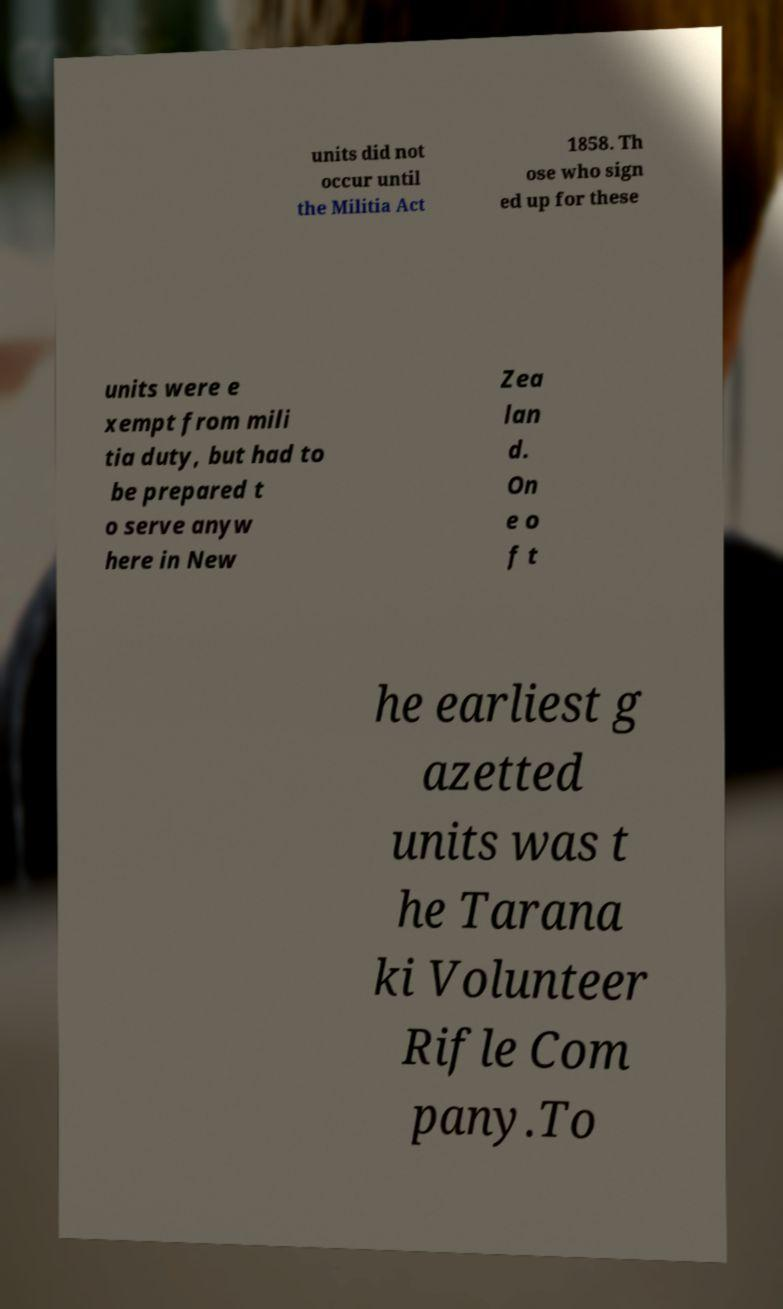For documentation purposes, I need the text within this image transcribed. Could you provide that? units did not occur until the Militia Act 1858. Th ose who sign ed up for these units were e xempt from mili tia duty, but had to be prepared t o serve anyw here in New Zea lan d. On e o f t he earliest g azetted units was t he Tarana ki Volunteer Rifle Com pany.To 